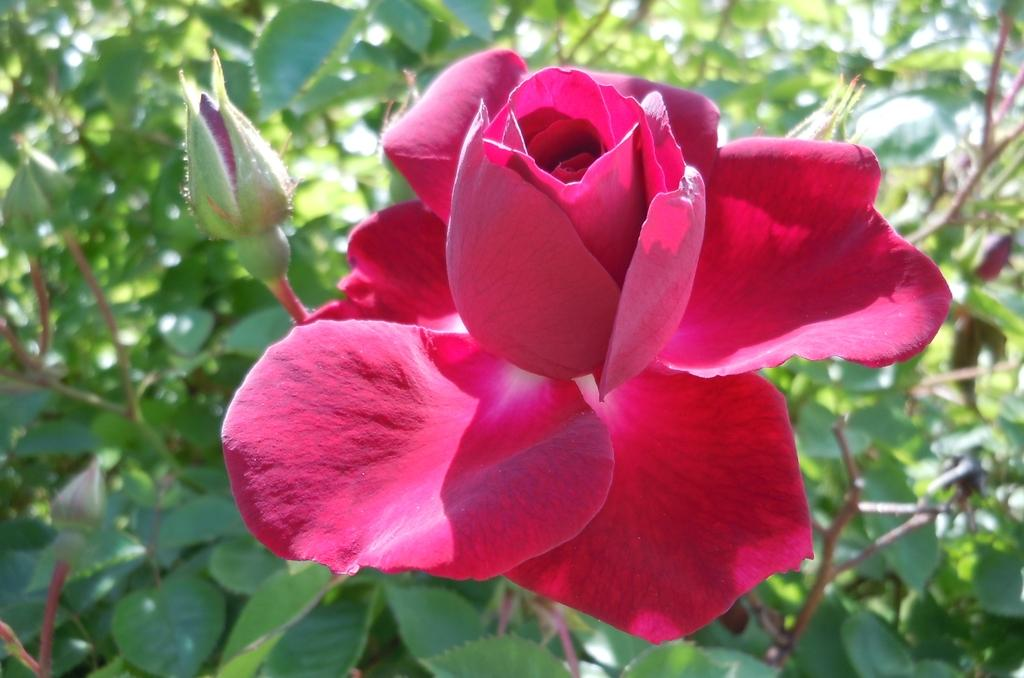What is the main subject in the center of the image? There is a rose in the center of the image. What can be seen on the left side of the image? There are buds on the left side of the image. What type of vegetation is visible in the background of the image? There is greenery in the background of the image. Is there any quicksand visible in the image? No, there is no quicksand present in the image. Can you read any letters on the rose in the image? There are no letters visible on the rose in the image. 